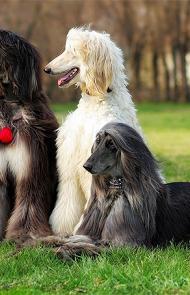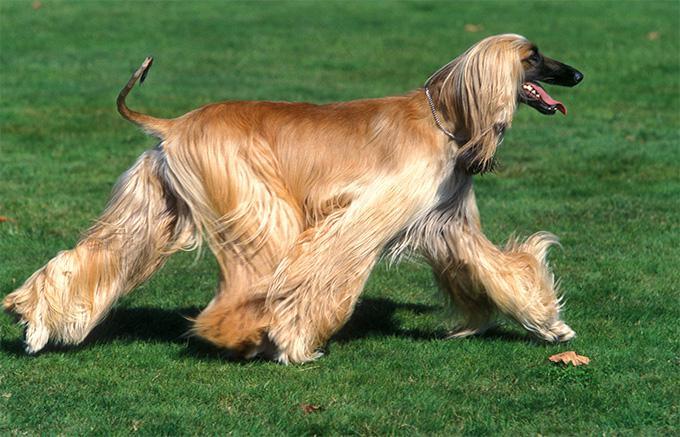The first image is the image on the left, the second image is the image on the right. Evaluate the accuracy of this statement regarding the images: "there is one dog lying down in the image on the left". Is it true? Answer yes or no. Yes. The first image is the image on the left, the second image is the image on the right. Considering the images on both sides, is "At least one dog has black fur." valid? Answer yes or no. Yes. 